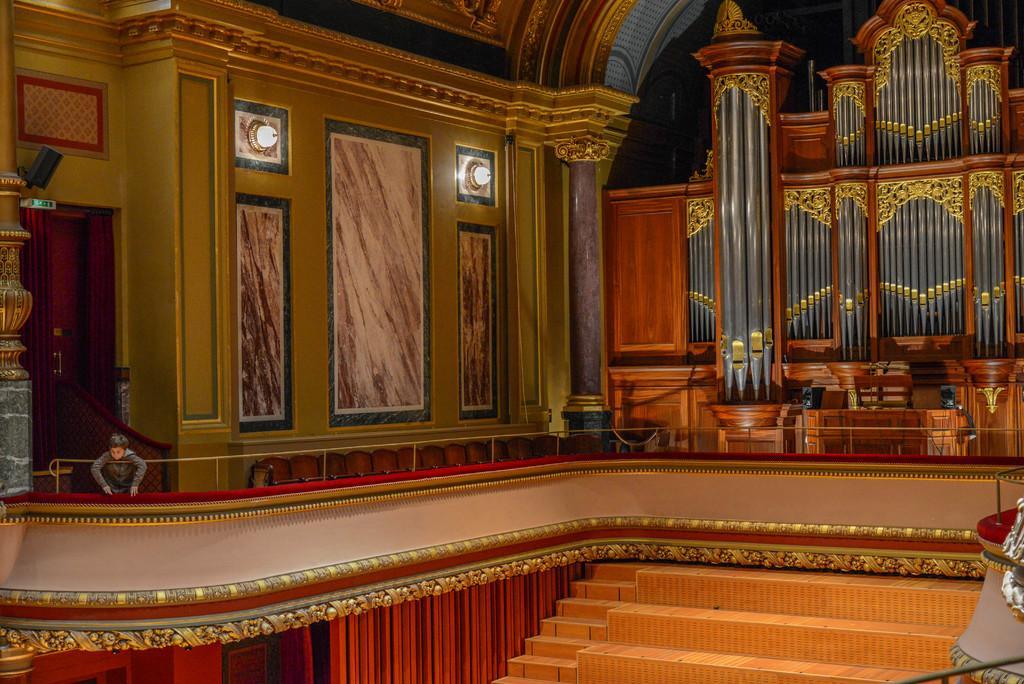Describe this image in one or two sentences. This picture is an inside view of a room. In this picture we can see wall, lights, pillars, speaker, board, door, person, stairs are there. 